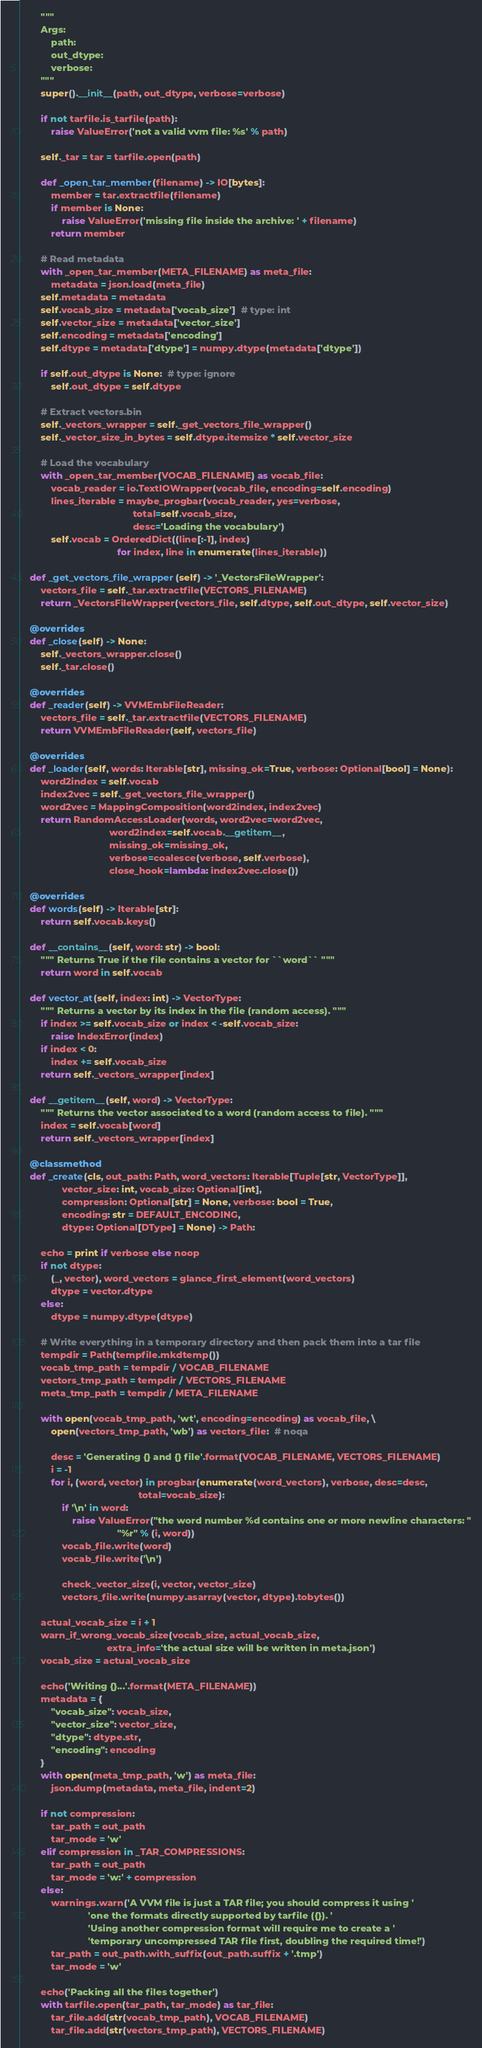Convert code to text. <code><loc_0><loc_0><loc_500><loc_500><_Python_>        """
        Args:
            path:
            out_dtype:
            verbose:
        """
        super().__init__(path, out_dtype, verbose=verbose)

        if not tarfile.is_tarfile(path):
            raise ValueError('not a valid vvm file: %s' % path)

        self._tar = tar = tarfile.open(path)

        def _open_tar_member(filename) -> IO[bytes]:
            member = tar.extractfile(filename)
            if member is None:
                raise ValueError('missing file inside the archive: ' + filename)
            return member

        # Read metadata
        with _open_tar_member(META_FILENAME) as meta_file:
            metadata = json.load(meta_file)
        self.metadata = metadata
        self.vocab_size = metadata['vocab_size']  # type: int
        self.vector_size = metadata['vector_size']
        self.encoding = metadata['encoding']
        self.dtype = metadata['dtype'] = numpy.dtype(metadata['dtype'])

        if self.out_dtype is None:  # type: ignore
            self.out_dtype = self.dtype

        # Extract vectors.bin
        self._vectors_wrapper = self._get_vectors_file_wrapper()
        self._vector_size_in_bytes = self.dtype.itemsize * self.vector_size

        # Load the vocabulary
        with _open_tar_member(VOCAB_FILENAME) as vocab_file:
            vocab_reader = io.TextIOWrapper(vocab_file, encoding=self.encoding)
            lines_iterable = maybe_progbar(vocab_reader, yes=verbose,
                                           total=self.vocab_size,
                                           desc='Loading the vocabulary')
            self.vocab = OrderedDict((line[:-1], index)
                                     for index, line in enumerate(lines_iterable))

    def _get_vectors_file_wrapper(self) -> '_VectorsFileWrapper':
        vectors_file = self._tar.extractfile(VECTORS_FILENAME)
        return _VectorsFileWrapper(vectors_file, self.dtype, self.out_dtype, self.vector_size)

    @overrides
    def _close(self) -> None:
        self._vectors_wrapper.close()
        self._tar.close()

    @overrides
    def _reader(self) -> VVMEmbFileReader:
        vectors_file = self._tar.extractfile(VECTORS_FILENAME)
        return VVMEmbFileReader(self, vectors_file)

    @overrides
    def _loader(self, words: Iterable[str], missing_ok=True, verbose: Optional[bool] = None):
        word2index = self.vocab
        index2vec = self._get_vectors_file_wrapper()
        word2vec = MappingComposition(word2index, index2vec)
        return RandomAccessLoader(words, word2vec=word2vec,
                                  word2index=self.vocab.__getitem__,
                                  missing_ok=missing_ok,
                                  verbose=coalesce(verbose, self.verbose),
                                  close_hook=lambda: index2vec.close())

    @overrides
    def words(self) -> Iterable[str]:
        return self.vocab.keys()

    def __contains__(self, word: str) -> bool:
        """ Returns True if the file contains a vector for ``word`` """
        return word in self.vocab

    def vector_at(self, index: int) -> VectorType:
        """ Returns a vector by its index in the file (random access). """
        if index >= self.vocab_size or index < -self.vocab_size:
            raise IndexError(index)
        if index < 0:
            index += self.vocab_size
        return self._vectors_wrapper[index]

    def __getitem__(self, word) -> VectorType:
        """ Returns the vector associated to a word (random access to file). """
        index = self.vocab[word]
        return self._vectors_wrapper[index]

    @classmethod
    def _create(cls, out_path: Path, word_vectors: Iterable[Tuple[str, VectorType]],
                vector_size: int, vocab_size: Optional[int],
                compression: Optional[str] = None, verbose: bool = True,
                encoding: str = DEFAULT_ENCODING,
                dtype: Optional[DType] = None) -> Path:

        echo = print if verbose else noop
        if not dtype:
            (_, vector), word_vectors = glance_first_element(word_vectors)
            dtype = vector.dtype
        else:
            dtype = numpy.dtype(dtype)

        # Write everything in a temporary directory and then pack them into a tar file
        tempdir = Path(tempfile.mkdtemp())
        vocab_tmp_path = tempdir / VOCAB_FILENAME
        vectors_tmp_path = tempdir / VECTORS_FILENAME
        meta_tmp_path = tempdir / META_FILENAME

        with open(vocab_tmp_path, 'wt', encoding=encoding) as vocab_file, \
            open(vectors_tmp_path, 'wb') as vectors_file:  # noqa

            desc = 'Generating {} and {} file'.format(VOCAB_FILENAME, VECTORS_FILENAME)
            i = -1
            for i, (word, vector) in progbar(enumerate(word_vectors), verbose, desc=desc,
                                             total=vocab_size):
                if '\n' in word:
                    raise ValueError("the word number %d contains one or more newline characters: "
                                     "%r" % (i, word))
                vocab_file.write(word)
                vocab_file.write('\n')

                check_vector_size(i, vector, vector_size)
                vectors_file.write(numpy.asarray(vector, dtype).tobytes())

        actual_vocab_size = i + 1
        warn_if_wrong_vocab_size(vocab_size, actual_vocab_size,
                                 extra_info='the actual size will be written in meta.json')
        vocab_size = actual_vocab_size

        echo('Writing {}...'.format(META_FILENAME))
        metadata = {
            "vocab_size": vocab_size,
            "vector_size": vector_size,
            "dtype": dtype.str,
            "encoding": encoding
        }
        with open(meta_tmp_path, 'w') as meta_file:
            json.dump(metadata, meta_file, indent=2)

        if not compression:
            tar_path = out_path
            tar_mode = 'w'
        elif compression in _TAR_COMPRESSIONS:
            tar_path = out_path
            tar_mode = 'w:' + compression
        else:
            warnings.warn('A VVM file is just a TAR file; you should compress it using '
                          'one the formats directly supported by tarfile ({}). '
                          'Using another compression format will require me to create a '
                          'temporary uncompressed TAR file first, doubling the required time!')
            tar_path = out_path.with_suffix(out_path.suffix + '.tmp')
            tar_mode = 'w'

        echo('Packing all the files together')
        with tarfile.open(tar_path, tar_mode) as tar_file:
            tar_file.add(str(vocab_tmp_path), VOCAB_FILENAME)
            tar_file.add(str(vectors_tmp_path), VECTORS_FILENAME)</code> 